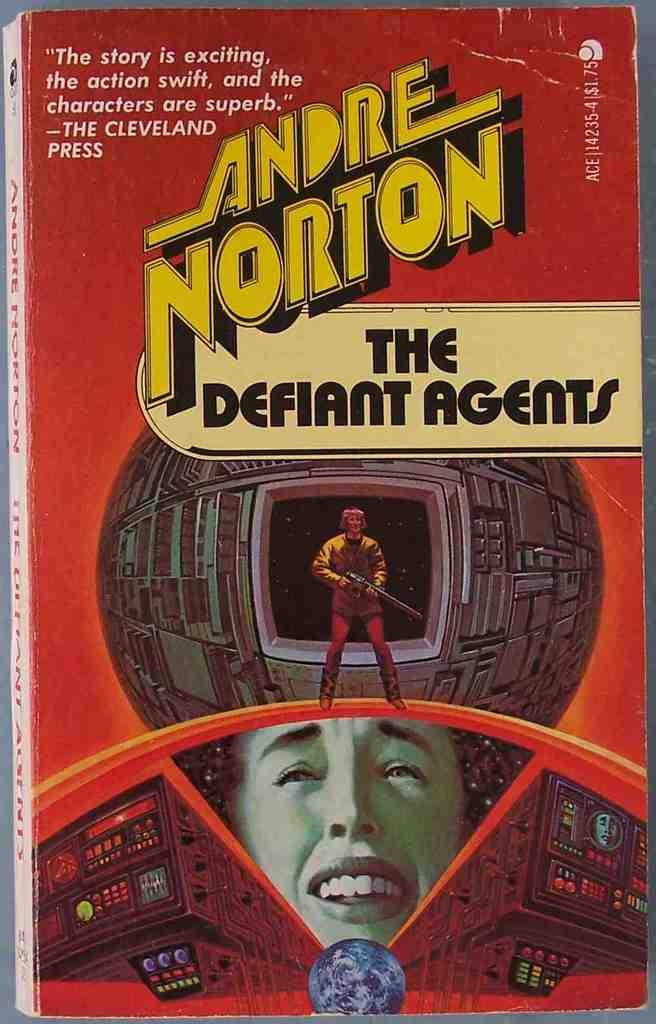Provide a one-sentence caption for the provided image. A book by Andre Norton called The Defiant Agents. 